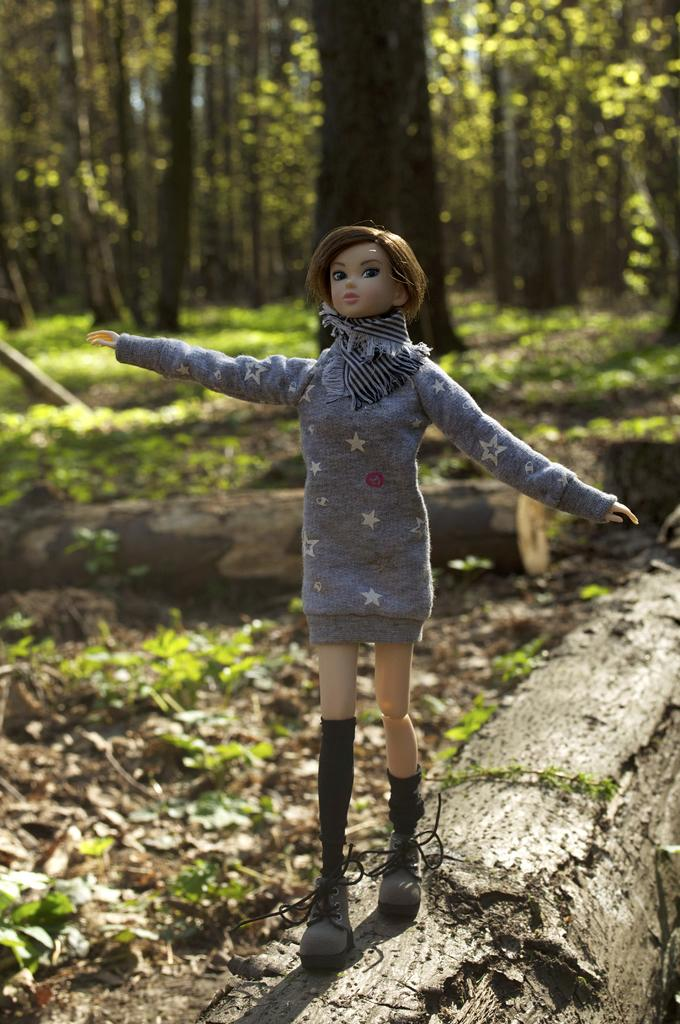What is placed on a wood log in the image? There is a doll on a wood log in the image. What else can be seen in the background of the image? There are wood logs, a group of trees, and plants in the background of the image. What type of flower is growing on the doll's head in the image? There is no flower growing on the doll's head in the image. 